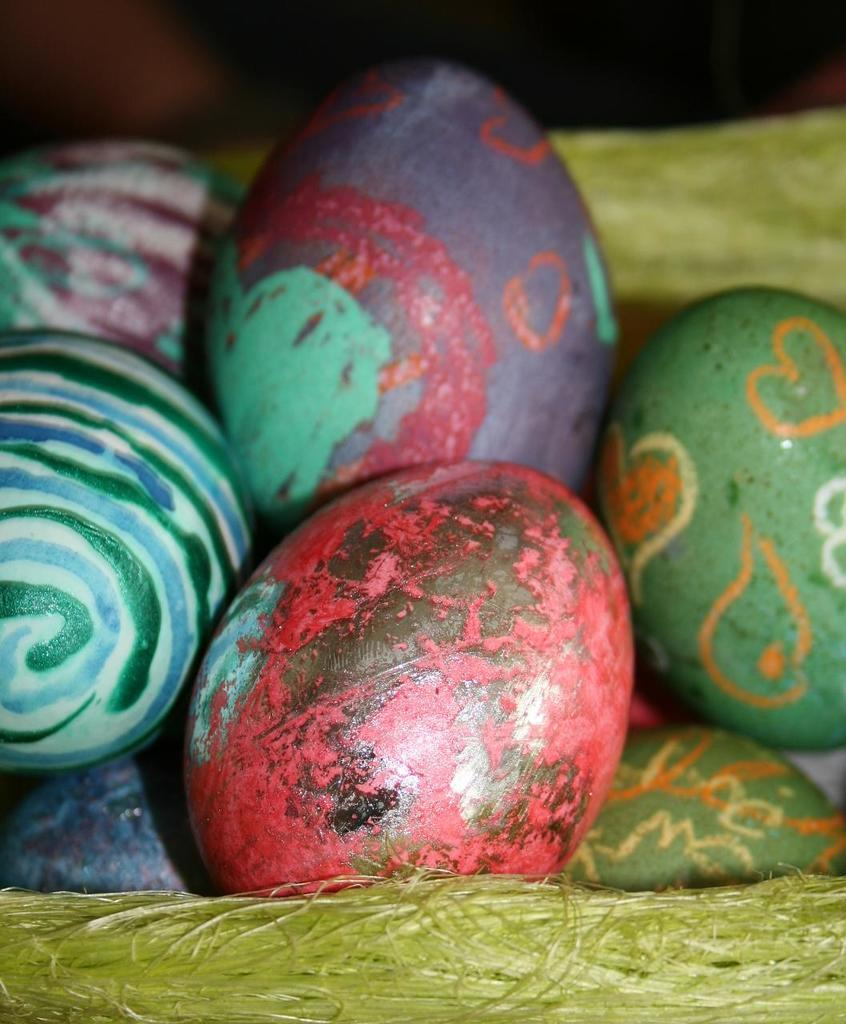What objects are present in the image? There are eggs in the image. What is the condition of the eggs? The eggs have paint on them. Where are the eggs located? The eggs are on a nest. What color can be seen at the top of the image? There is a black color visible at the top of the image. What type of flower is being used for arithmetic calculations in the image? There is no flower or arithmetic calculations present in the image. What color is the crayon used to draw on the eggs in the image? There is no crayon or drawing on the eggs in the image; the eggs have paint on them. 